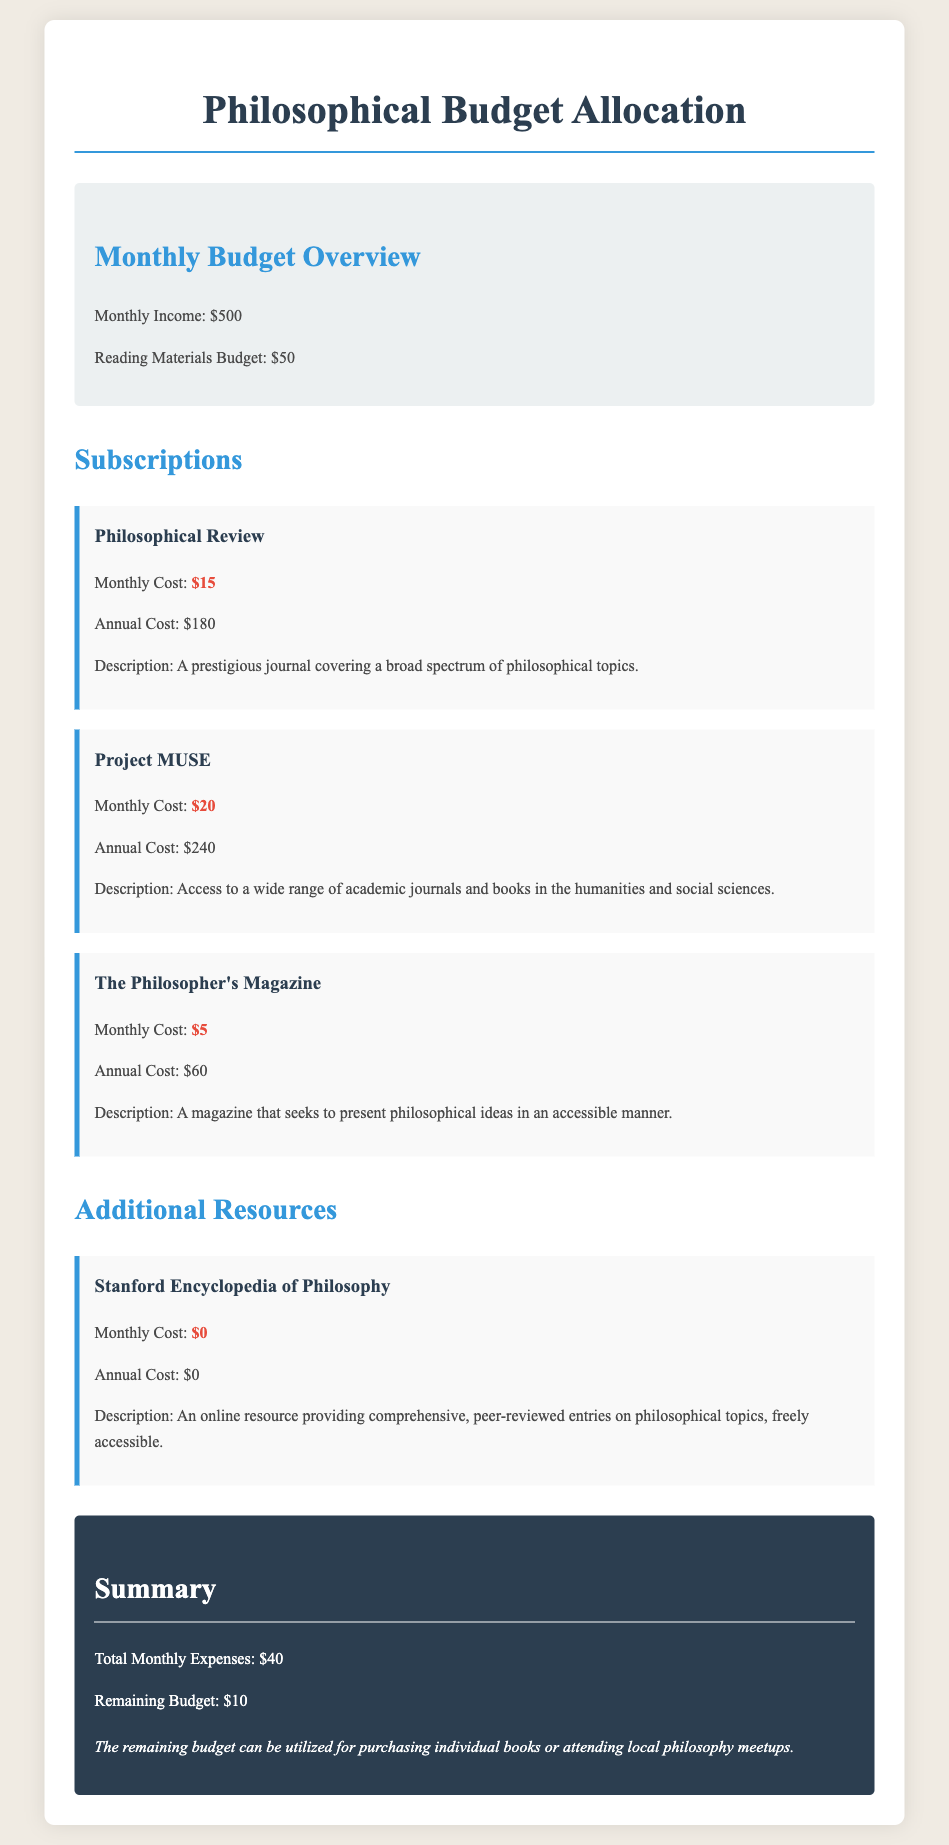What is the monthly reading materials budget? The document states the reading materials budget as $50.
Answer: $50 How much does the Philosophical Review cost monthly? The monthly cost of the Philosophical Review is indicated in the document as $15.
Answer: $15 What is the total monthly expense for subscriptions? The document sums up the monthly expenses to be $40.
Answer: $40 What is the remaining budget after expenses? The remaining budget after totaling the expenses is reported as $10.
Answer: $10 Which resource has a monthly cost of zero? The document specifies that the Stanford Encyclopedia of Philosophy has a monthly cost of $0.
Answer: Stanford Encyclopedia of Philosophy What is the annual cost of Project MUSE? The document lists the annual cost of Project MUSE as $240.
Answer: $240 What type of resource is The Philosopher's Magazine? The document describes The Philosopher's Magazine as a magazine that presents philosophical ideas.
Answer: Magazine What is the total annual cost of the Philosophical Review? The annual cost for the Philosophical Review is shown in the document as $180.
Answer: $180 What can the remaining budget be used for? The document suggests that the remaining budget can be utilized for purchasing individual books or attending local philosophy meetups.
Answer: Purchasing individual books or attending local philosophy meetups 